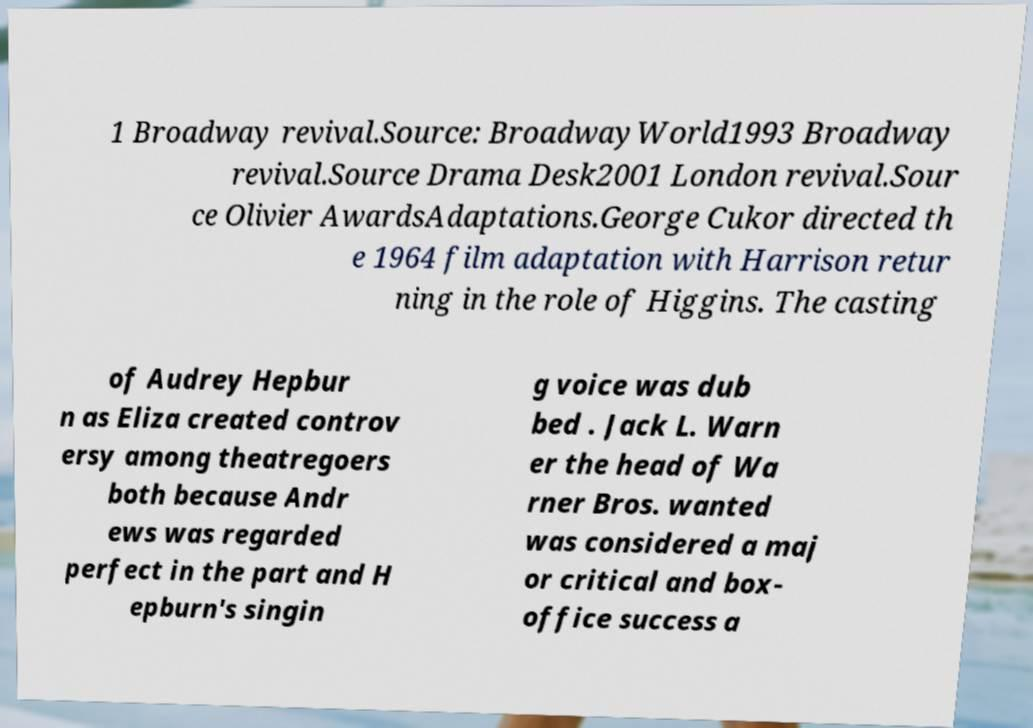Can you read and provide the text displayed in the image?This photo seems to have some interesting text. Can you extract and type it out for me? 1 Broadway revival.Source: BroadwayWorld1993 Broadway revival.Source Drama Desk2001 London revival.Sour ce Olivier AwardsAdaptations.George Cukor directed th e 1964 film adaptation with Harrison retur ning in the role of Higgins. The casting of Audrey Hepbur n as Eliza created controv ersy among theatregoers both because Andr ews was regarded perfect in the part and H epburn's singin g voice was dub bed . Jack L. Warn er the head of Wa rner Bros. wanted was considered a maj or critical and box- office success a 